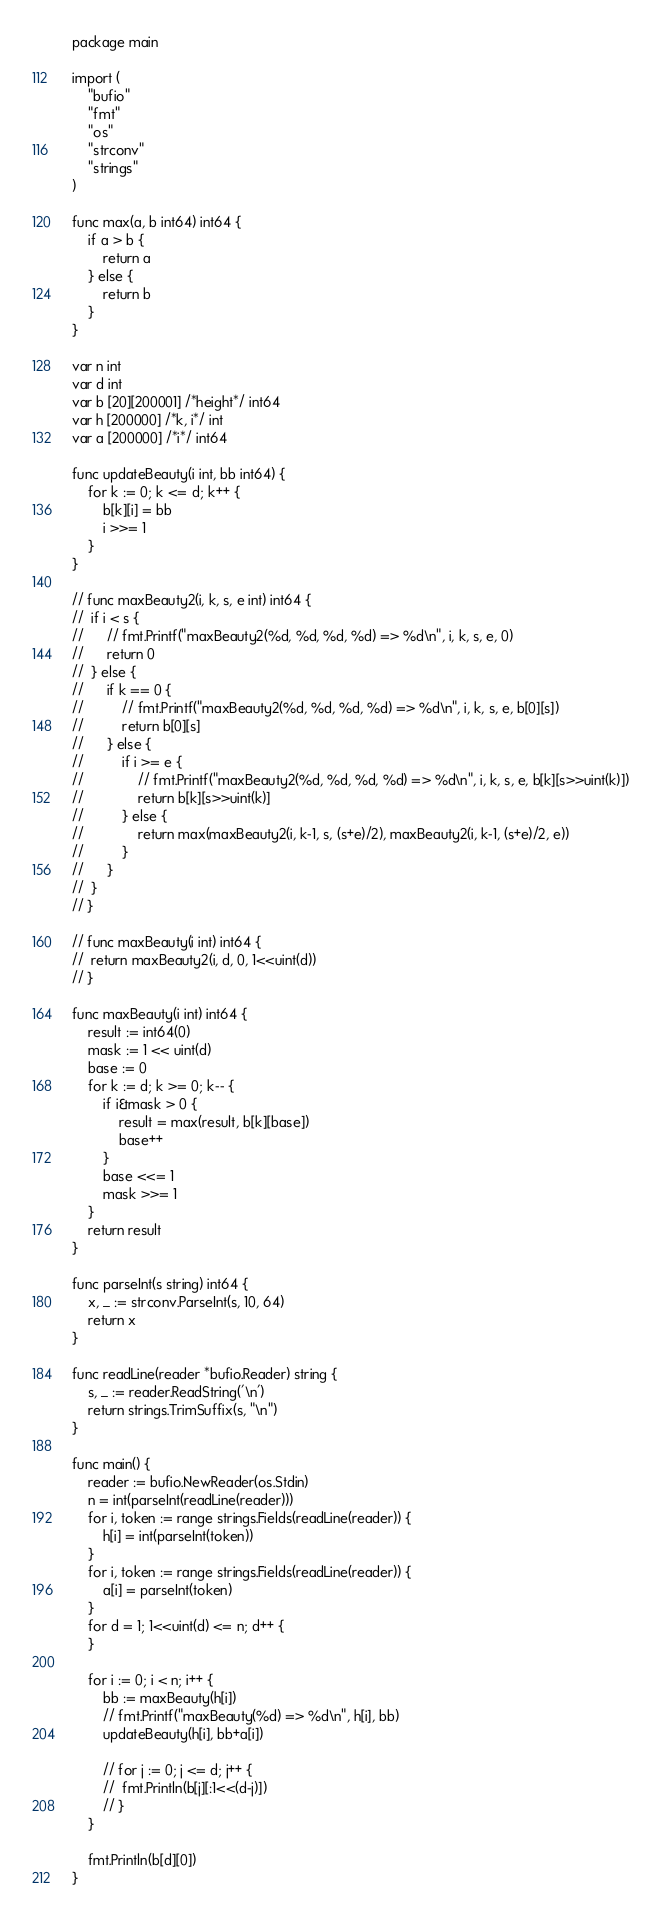Convert code to text. <code><loc_0><loc_0><loc_500><loc_500><_Go_>package main

import (
	"bufio"
	"fmt"
	"os"
	"strconv"
	"strings"
)

func max(a, b int64) int64 {
	if a > b {
		return a
	} else {
		return b
	}
}

var n int
var d int
var b [20][200001] /*height*/ int64
var h [200000] /*k, i*/ int
var a [200000] /*i*/ int64

func updateBeauty(i int, bb int64) {
	for k := 0; k <= d; k++ {
		b[k][i] = bb
		i >>= 1
	}
}

// func maxBeauty2(i, k, s, e int) int64 {
// 	if i < s {
// 		// fmt.Printf("maxBeauty2(%d, %d, %d, %d) => %d\n", i, k, s, e, 0)
// 		return 0
// 	} else {
// 		if k == 0 {
// 			// fmt.Printf("maxBeauty2(%d, %d, %d, %d) => %d\n", i, k, s, e, b[0][s])
// 			return b[0][s]
// 		} else {
// 			if i >= e {
// 				// fmt.Printf("maxBeauty2(%d, %d, %d, %d) => %d\n", i, k, s, e, b[k][s>>uint(k)])
// 				return b[k][s>>uint(k)]
// 			} else {
// 				return max(maxBeauty2(i, k-1, s, (s+e)/2), maxBeauty2(i, k-1, (s+e)/2, e))
// 			}
// 		}
// 	}
// }

// func maxBeauty(i int) int64 {
// 	return maxBeauty2(i, d, 0, 1<<uint(d))
// }

func maxBeauty(i int) int64 {
	result := int64(0)
	mask := 1 << uint(d)
	base := 0
	for k := d; k >= 0; k-- {
		if i&mask > 0 {
			result = max(result, b[k][base])
			base++
		}
		base <<= 1
		mask >>= 1
	}
	return result
}

func parseInt(s string) int64 {
	x, _ := strconv.ParseInt(s, 10, 64)
	return x
}

func readLine(reader *bufio.Reader) string {
	s, _ := reader.ReadString('\n')
	return strings.TrimSuffix(s, "\n")
}

func main() {
	reader := bufio.NewReader(os.Stdin)
	n = int(parseInt(readLine(reader)))
	for i, token := range strings.Fields(readLine(reader)) {
		h[i] = int(parseInt(token))
	}
	for i, token := range strings.Fields(readLine(reader)) {
		a[i] = parseInt(token)
	}
	for d = 1; 1<<uint(d) <= n; d++ {
	}

	for i := 0; i < n; i++ {
		bb := maxBeauty(h[i])
		// fmt.Printf("maxBeauty(%d) => %d\n", h[i], bb)
		updateBeauty(h[i], bb+a[i])

		// for j := 0; j <= d; j++ {
		// 	fmt.Println(b[j][:1<<(d-j)])
		// }
	}

	fmt.Println(b[d][0])
}
</code> 